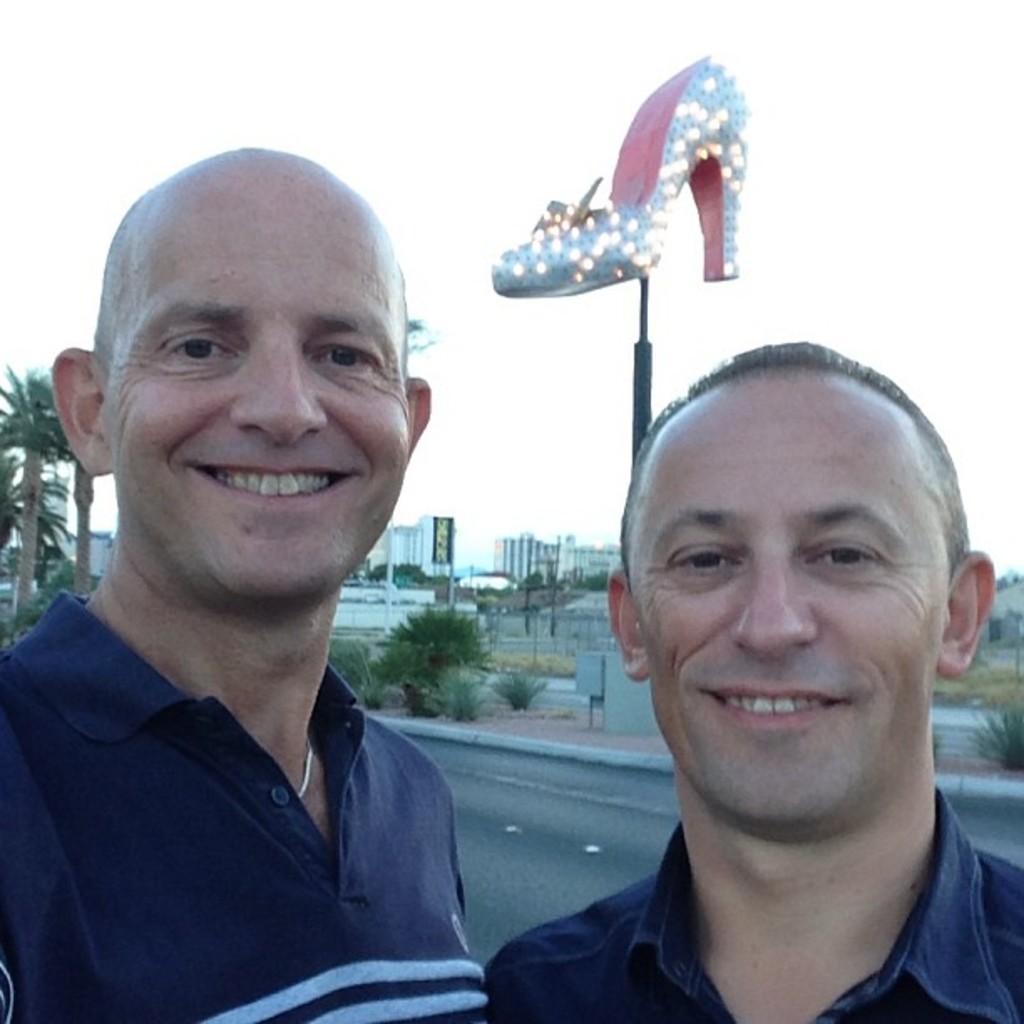How would you summarize this image in a sentence or two? In the image there are two men in the foreground and behind them there are trees, a sculpture of footwear and some buildings. 